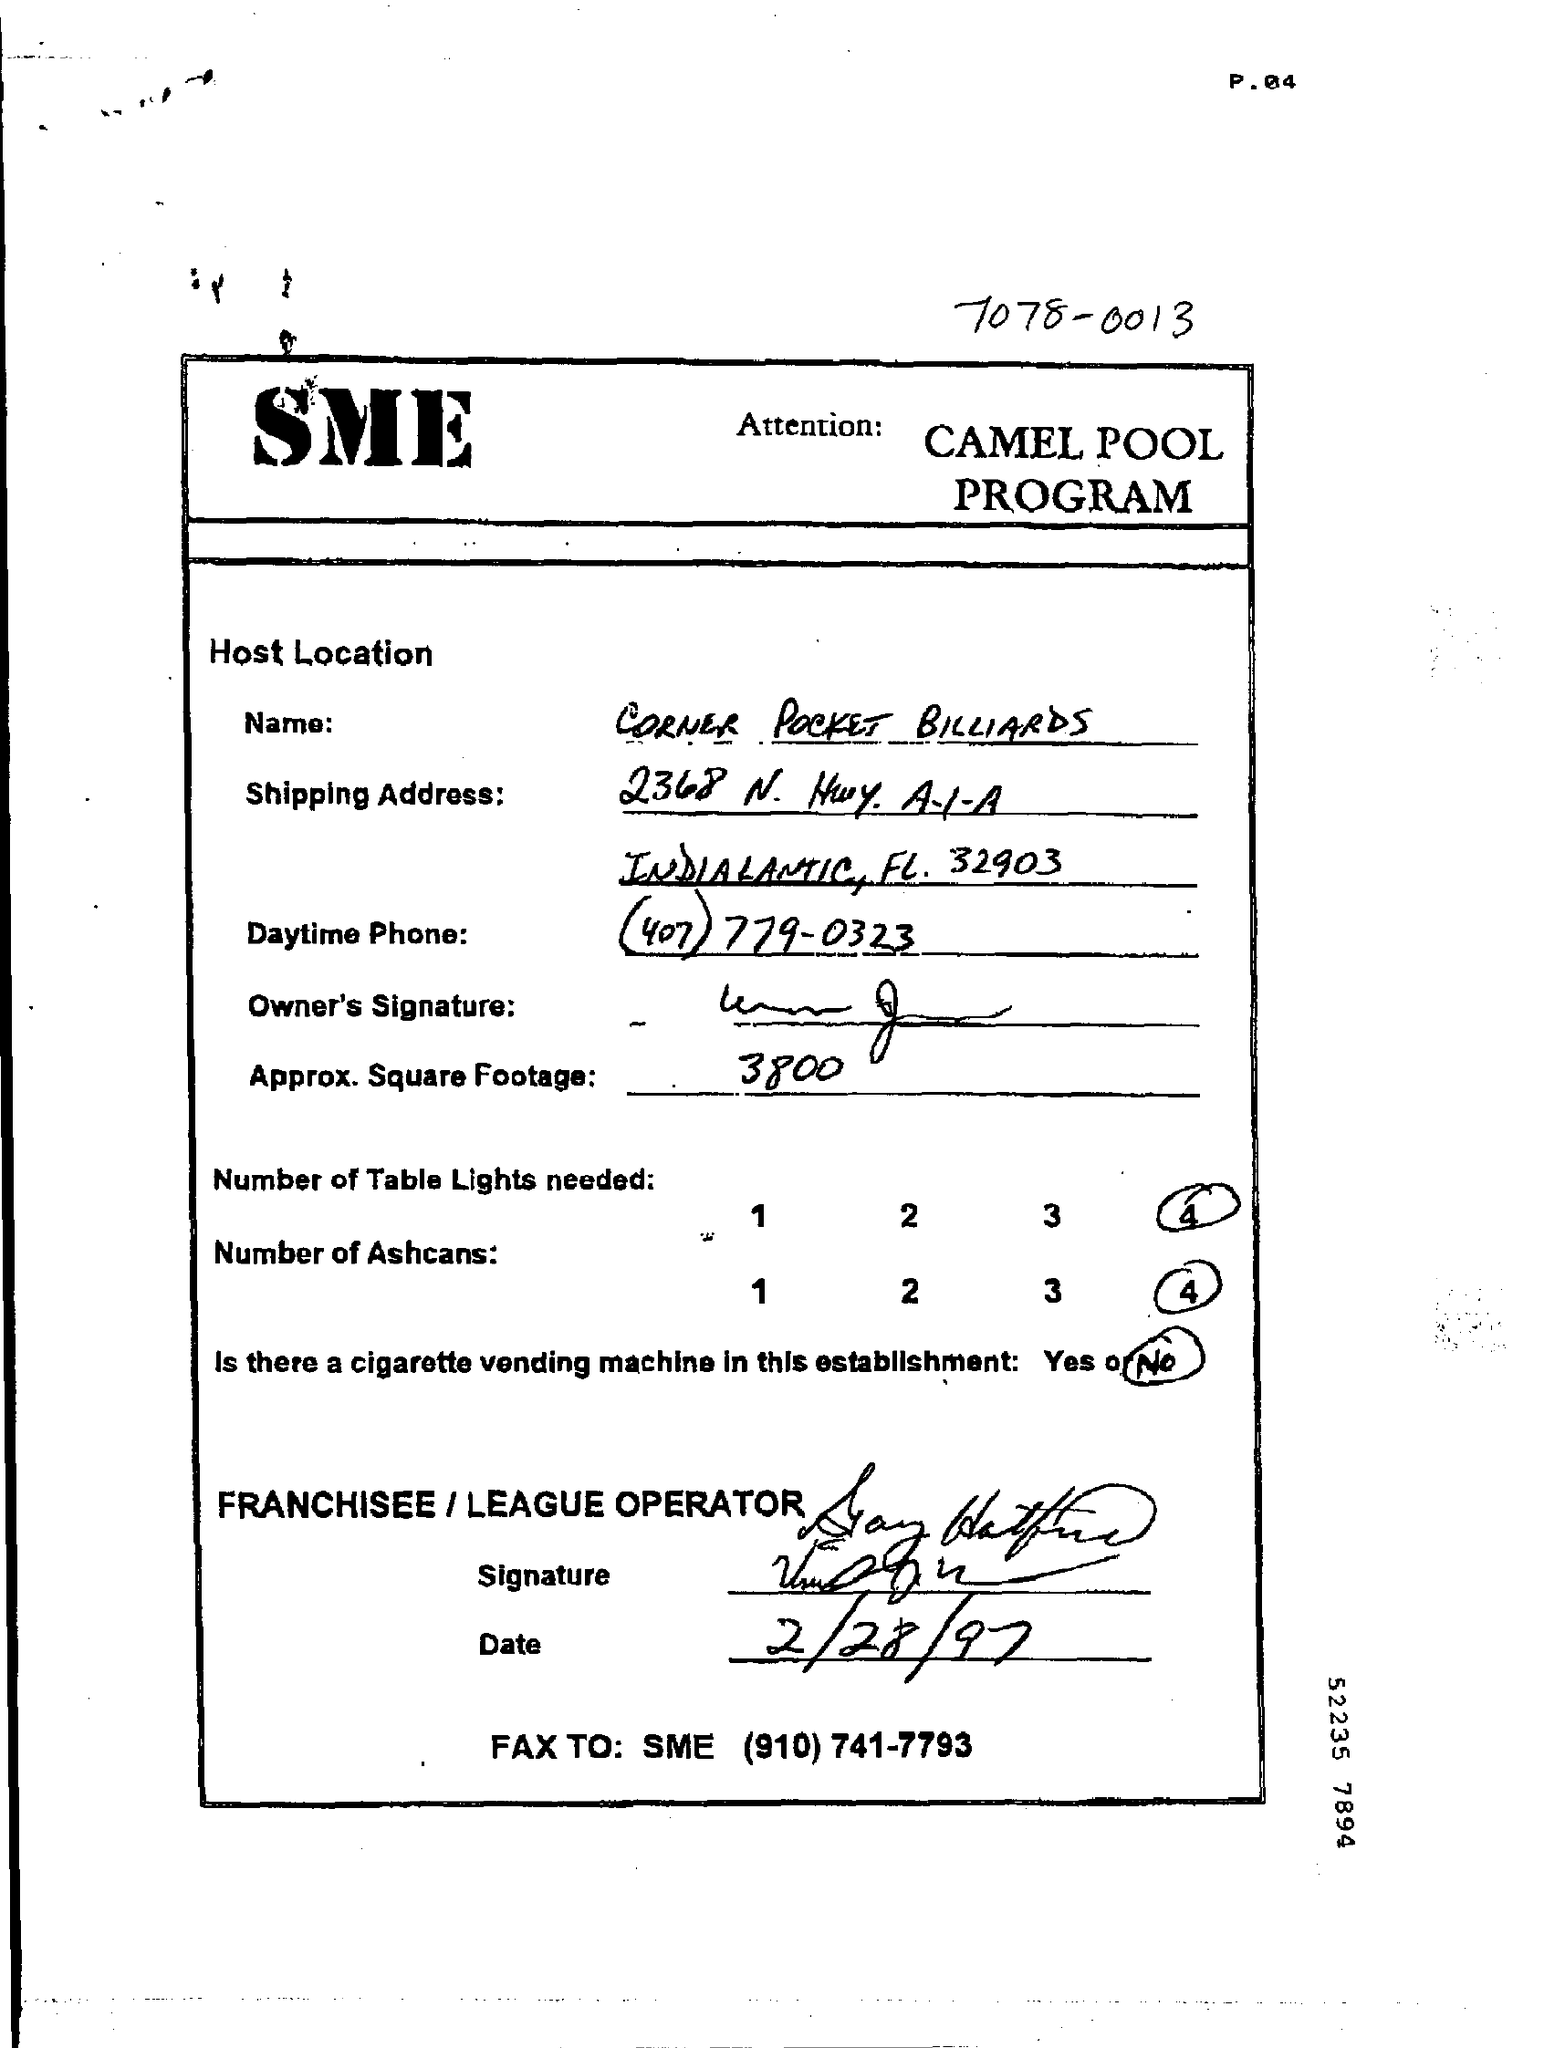What is the program name?
Provide a short and direct response. CAMEL POOL PROGRAM. What is the name given?
Offer a very short reply. CORNER POCKET BILLIARDS. What is the Approx. Square Footage?
Provide a succinct answer. 3800. How many Table Lights are needed?
Offer a terse response. 4. Is there a cigarette vending machine in this establishment?
Ensure brevity in your answer.  No. When is the document dated?
Give a very brief answer. 2/28/97. 